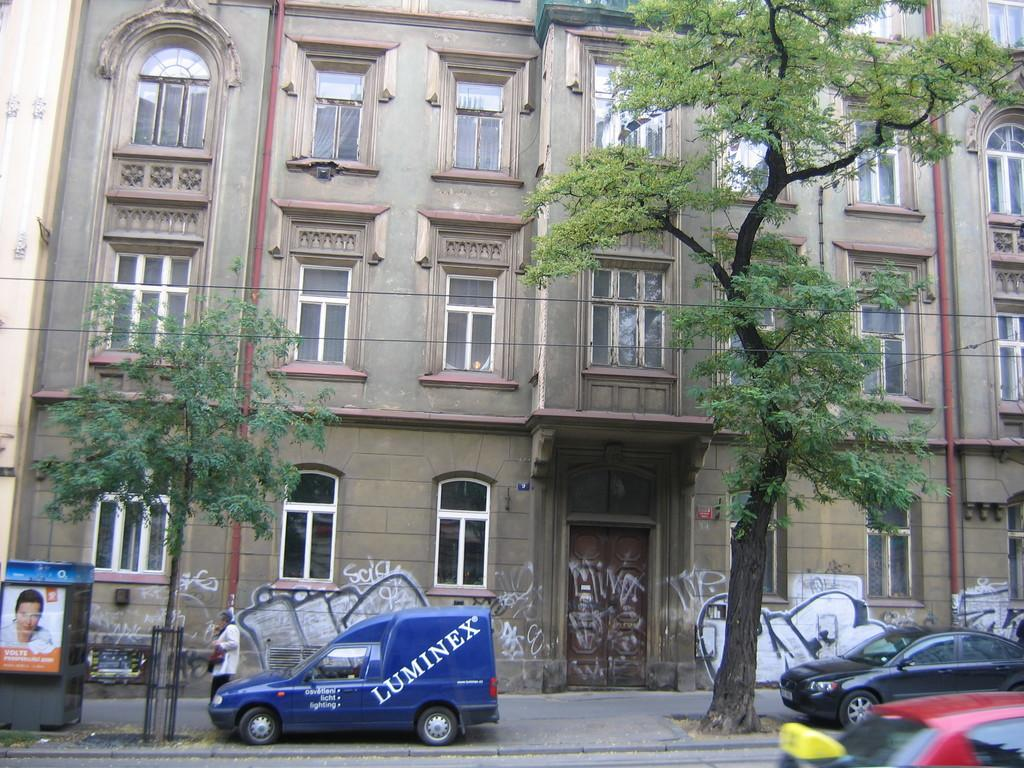<image>
Write a terse but informative summary of the picture. The blue small van sitting in front of the building has the word luminex written on it. 